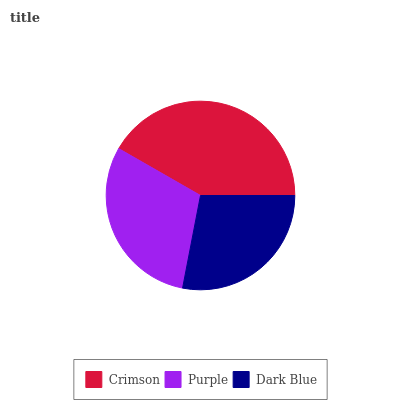Is Dark Blue the minimum?
Answer yes or no. Yes. Is Crimson the maximum?
Answer yes or no. Yes. Is Purple the minimum?
Answer yes or no. No. Is Purple the maximum?
Answer yes or no. No. Is Crimson greater than Purple?
Answer yes or no. Yes. Is Purple less than Crimson?
Answer yes or no. Yes. Is Purple greater than Crimson?
Answer yes or no. No. Is Crimson less than Purple?
Answer yes or no. No. Is Purple the high median?
Answer yes or no. Yes. Is Purple the low median?
Answer yes or no. Yes. Is Crimson the high median?
Answer yes or no. No. Is Crimson the low median?
Answer yes or no. No. 